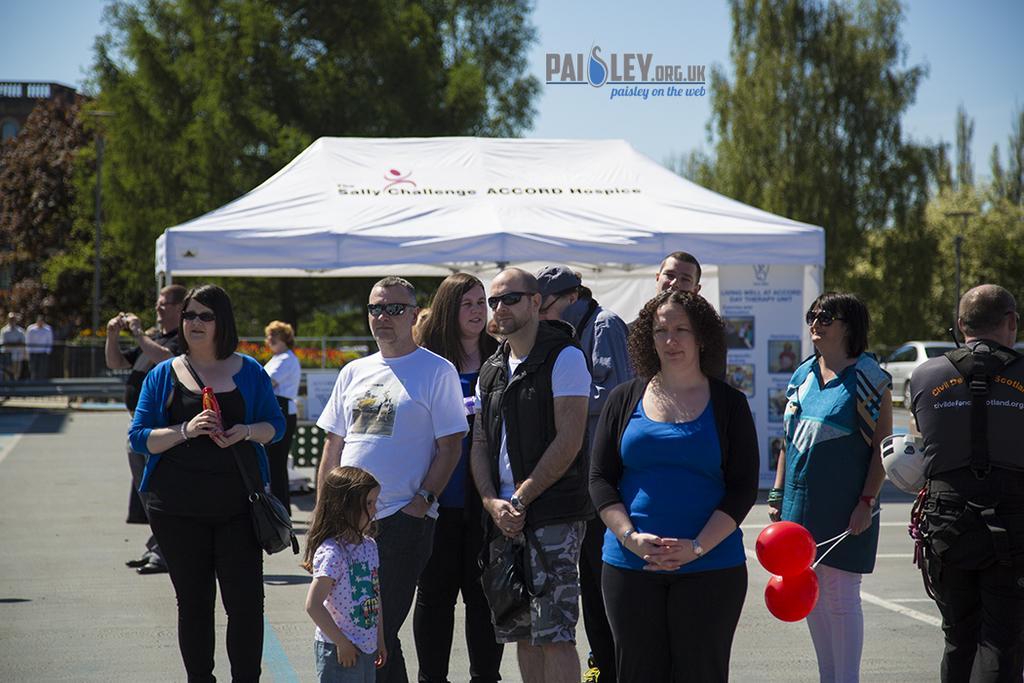Describe this image in one or two sentences. In this image few persons are standing on the road. Behind them there is a tent. Few persons are standing behind the fence. A woman wearing a blue jacket is holding a bottle in her hand and she is carrying a bag. A woman wearing a blue dress is holding balloons in her hand. Beside there is a person wearing a black shirt is having helmet. Behind there is a car on the road. Background there are few trees. Left top there is a building. Top of image there is sky. 